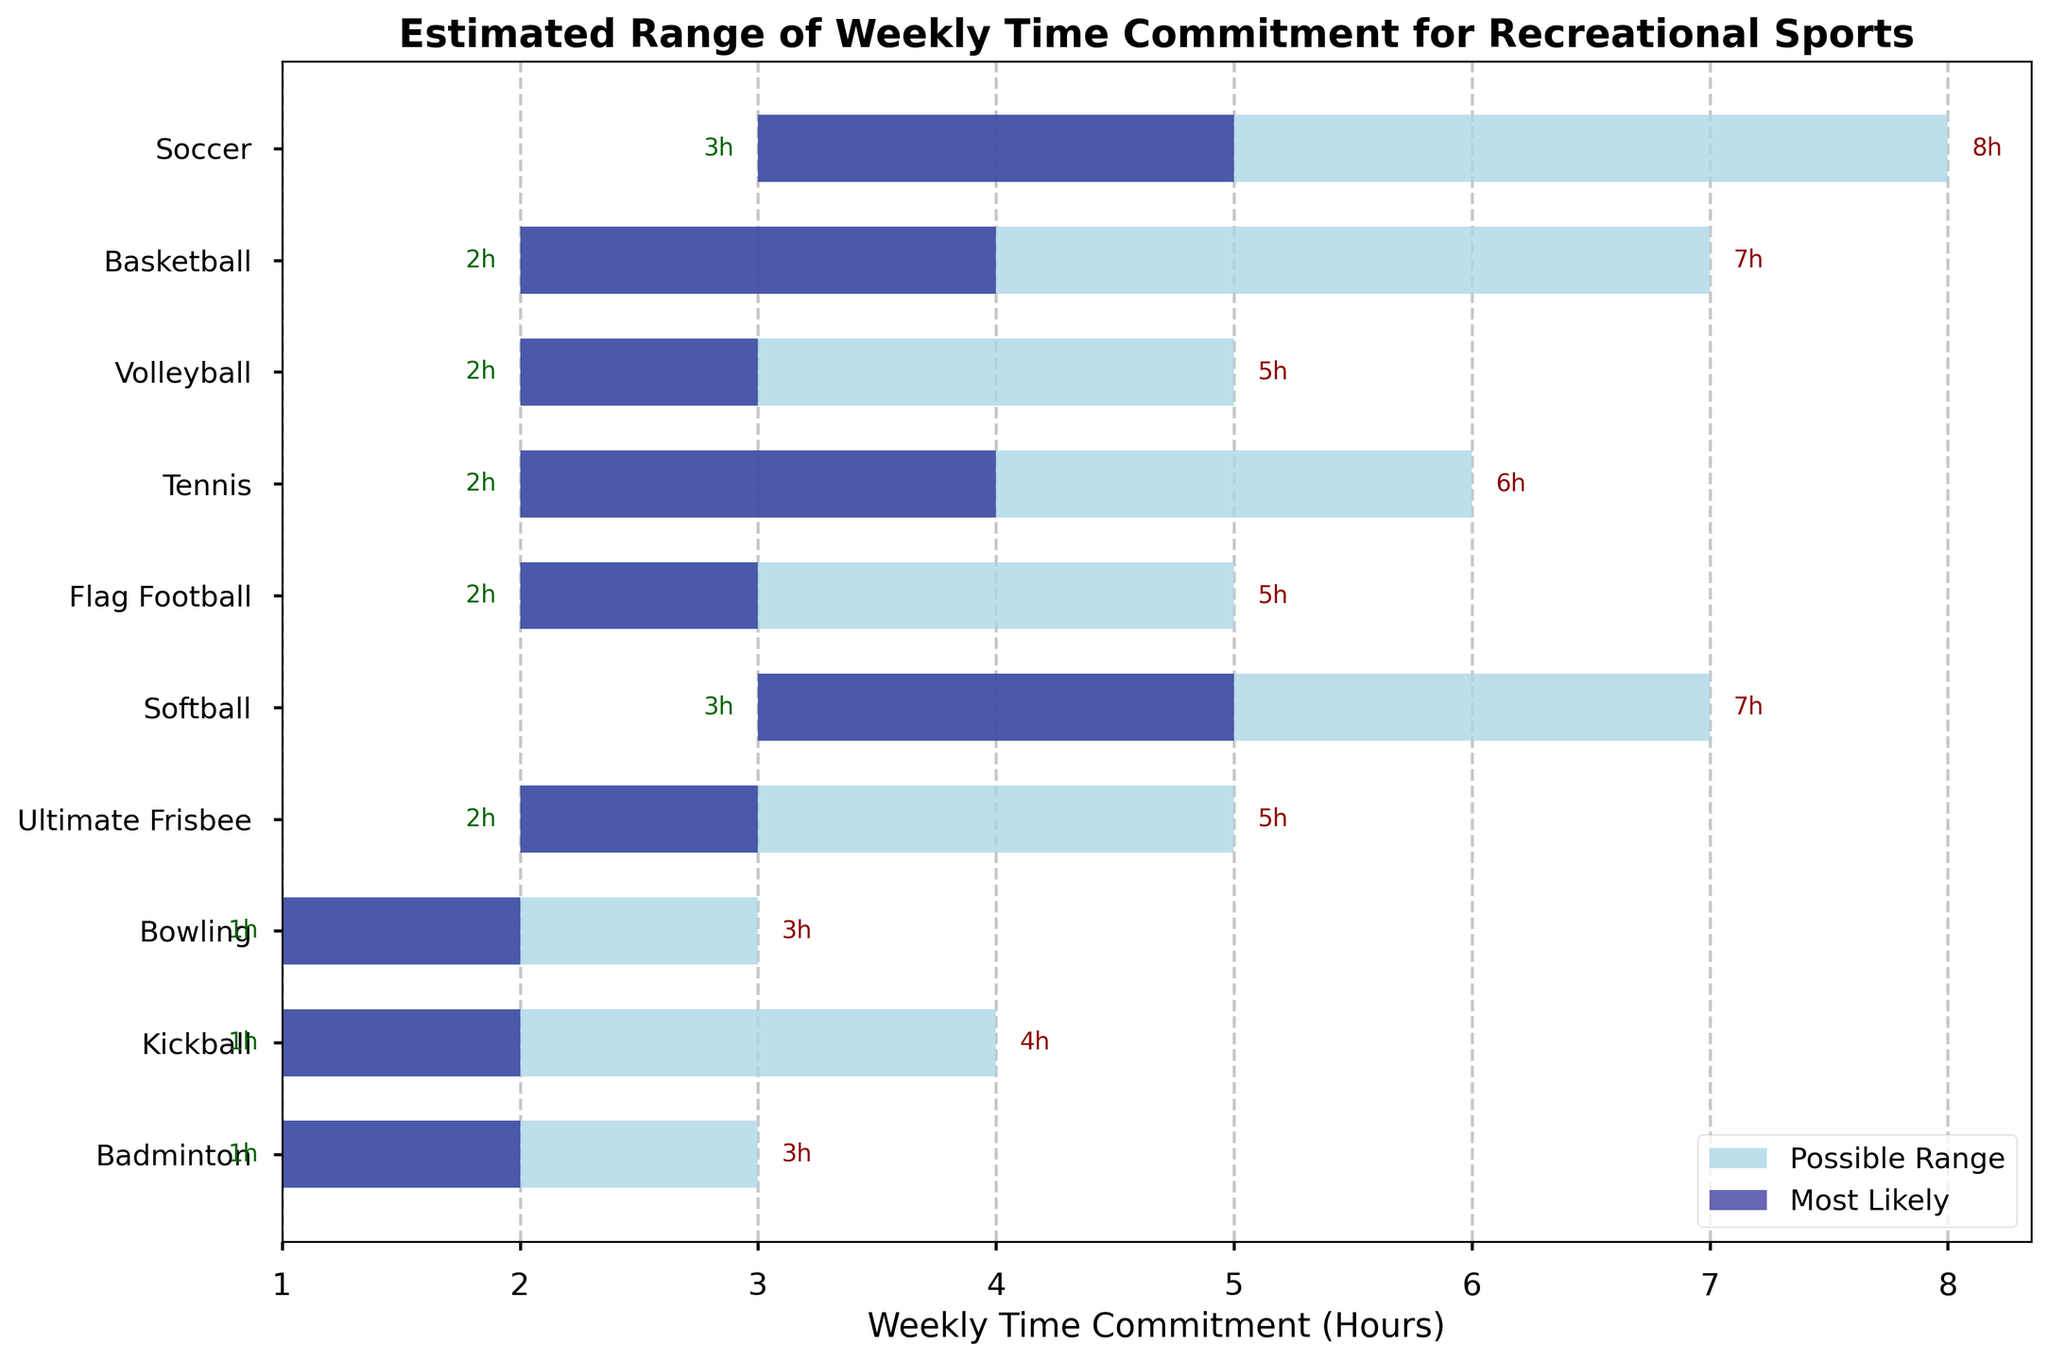What is the title of the chart? The title of the chart is usually found at the top and gives a brief description of the content.
Answer: Estimated Range of Weekly Time Commitment for Recreational Sports How many sports are listed in the chart? To determine the number of sports, count the labels on the y-axis.
Answer: 10 Which sport has the highest maximum weekly time commitment? To find this, look for the sport with the largest value at the end of the light blue bars.
Answer: Soccer Which sport has the lowest minimum weekly time commitment? To find the sport with the smallest starting value of the light blue bar, look for the bar that starts the earliest.
Answer: Bowling What is the approximate range of weekly time commitment for Volleyball? Subtract the minimum time from the maximum time for Volleyball.
Answer: 3 hours (5 - 2) How does the most likely time commitment for Soccer compare to that of Basketball? Compare the middle (navy) bar for Soccer and Basketball.
Answer: Soccer is higher Which sport has the smallest range of time commitment between the minimum and maximum hours? To find the smallest range, subtract the minimum time from the maximum time for each sport and determine the smallest result.
Answer: Bowling What is the most likely weekly time commitment for Tennis? Find the middle bar (navy) value for Tennis.
Answer: 4 hours How does Ultimate Frisbee compare to Kickball in terms of maximum time commitment? Compare the end of the light blue bars for Ultimate Frisbee and Kickball.
Answer: They are the same Arrange Soccer, Basketball, and Softball in order of their most likely weekly time commitment, from highest to lowest. Compare the middle (navy) bar values for Soccer, Basketball, and Softball, then order them accordingly.
Answer: Soccer, Softball, Basketball 